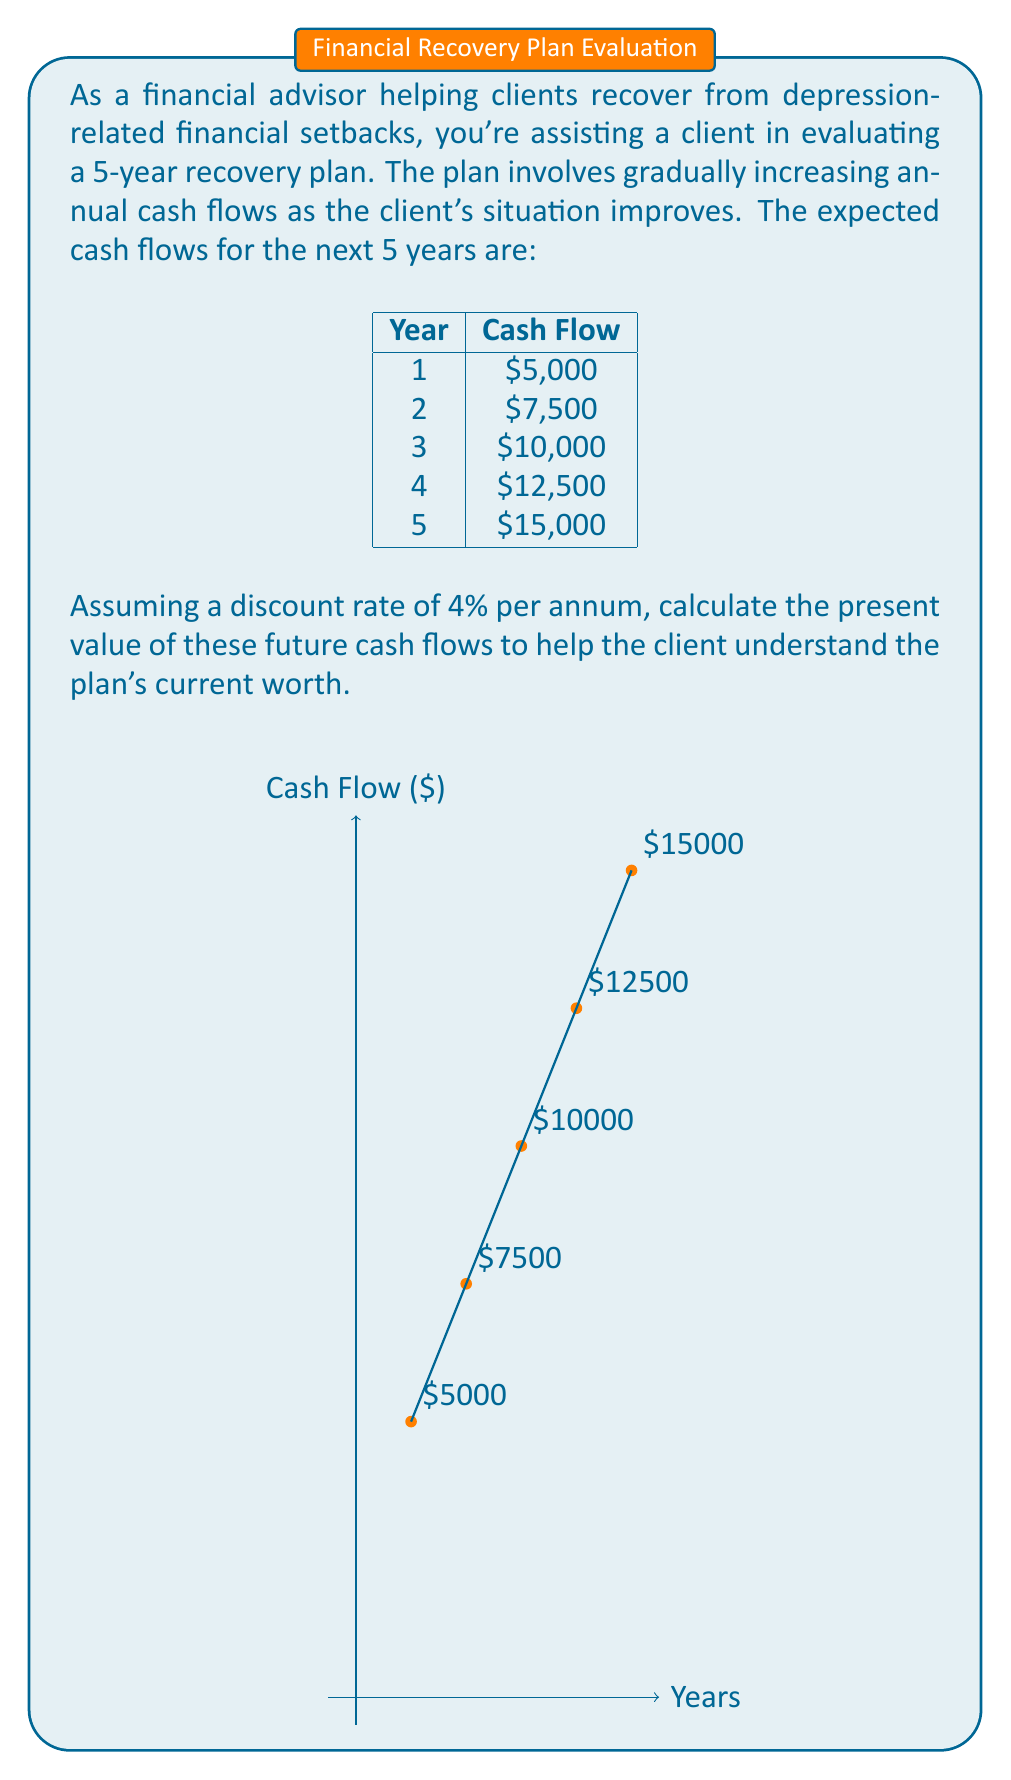Could you help me with this problem? To calculate the present value of future cash flows, we need to discount each cash flow back to the present using the given discount rate. The formula for the present value (PV) of a single cash flow is:

$$ PV = \frac{CF_t}{(1+r)^t} $$

Where:
$CF_t$ = Cash flow at time t
$r$ = Discount rate
$t$ = Time period

Let's calculate the present value for each year's cash flow:

Year 1: $PV_1 = \frac{5000}{(1+0.04)^1} = \frac{5000}{1.04} = 4807.69$

Year 2: $PV_2 = \frac{7500}{(1+0.04)^2} = \frac{7500}{1.0816} = 6934.73$

Year 3: $PV_3 = \frac{10000}{(1+0.04)^3} = \frac{10000}{1.124864} = 8889.96$

Year 4: $PV_4 = \frac{12500}{(1+0.04)^4} = \frac{12500}{1.16986} = 10685.65$

Year 5: $PV_5 = \frac{15000}{(1+0.04)^5} = \frac{15000}{1.21665} = 12329.92$

To get the total present value, we sum all these individual present values:

$$ Total\;PV = 4807.69 + 6934.73 + 8889.96 + 10685.65 + 12329.92 = 43647.95 $$

Therefore, the present value of the future cash flows in this depression recovery plan is $43,647.95.
Answer: $43,647.95 